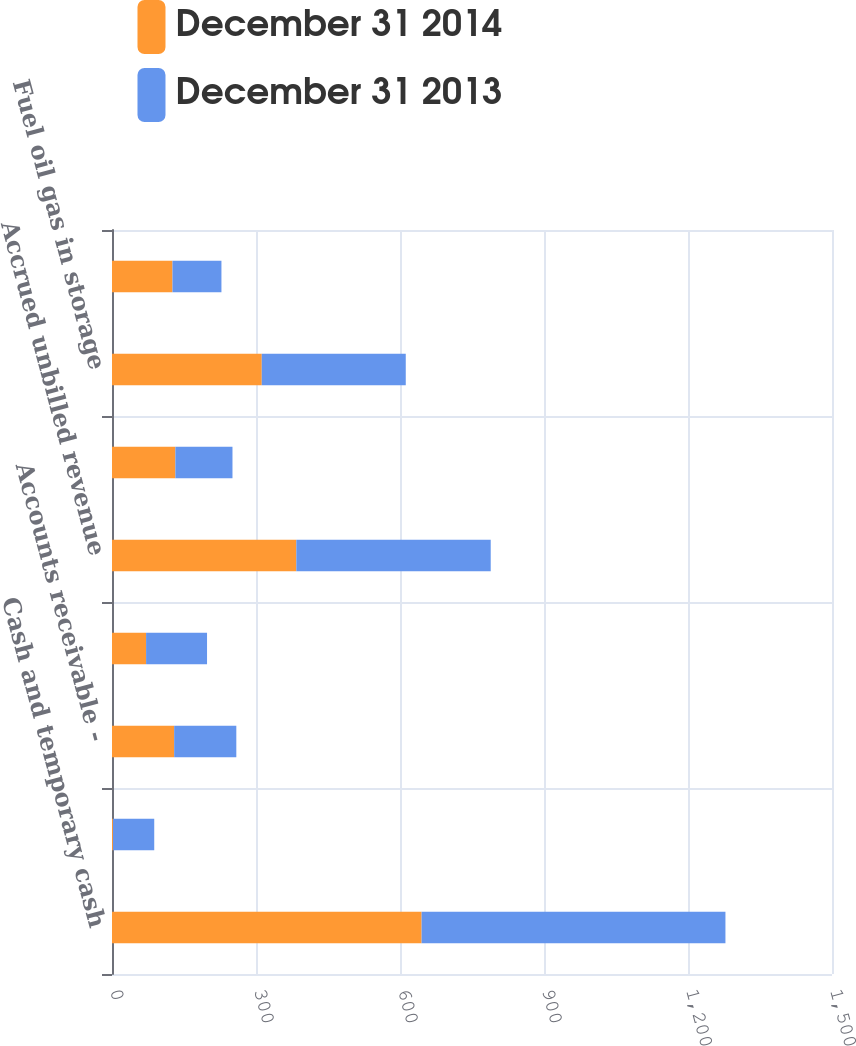Convert chart to OTSL. <chart><loc_0><loc_0><loc_500><loc_500><stacked_bar_chart><ecel><fcel>Cash and temporary cash<fcel>Special deposits<fcel>Accounts receivable -<fcel>Other receivables less<fcel>Accrued unbilled revenue<fcel>Accounts receivable from<fcel>Fuel oil gas in storage<fcel>Prepayments<nl><fcel>December 31 2014<fcel>645<fcel>2<fcel>129.5<fcel>71<fcel>384<fcel>132<fcel>312<fcel>126<nl><fcel>December 31 2013<fcel>633<fcel>86<fcel>129.5<fcel>127<fcel>405<fcel>119<fcel>300<fcel>102<nl></chart> 